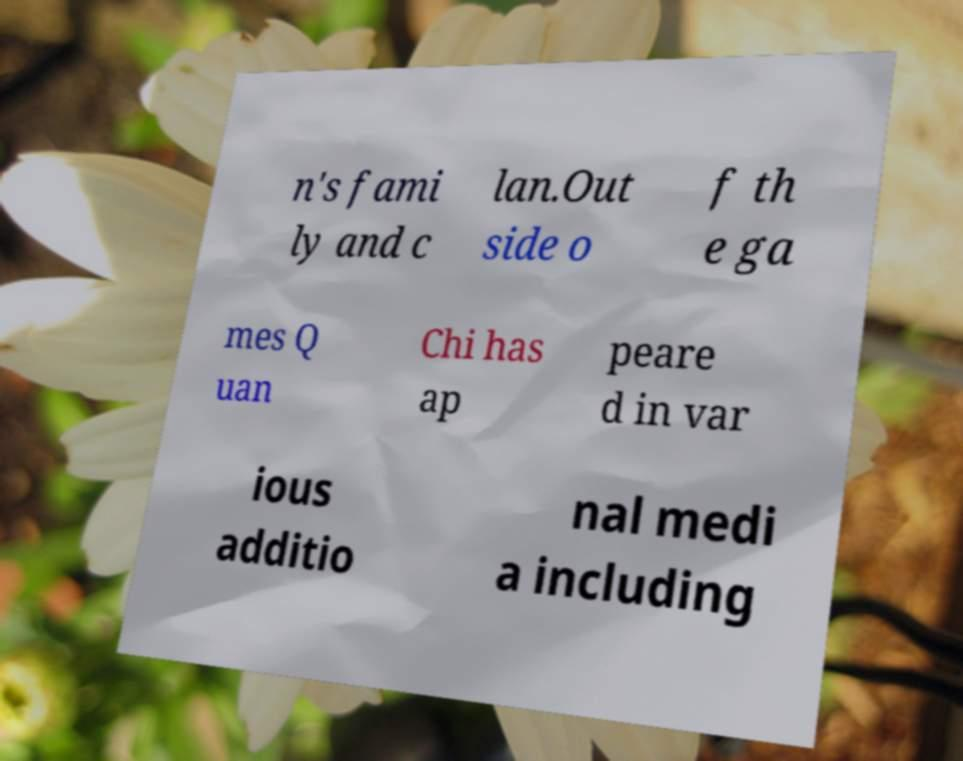For documentation purposes, I need the text within this image transcribed. Could you provide that? n's fami ly and c lan.Out side o f th e ga mes Q uan Chi has ap peare d in var ious additio nal medi a including 